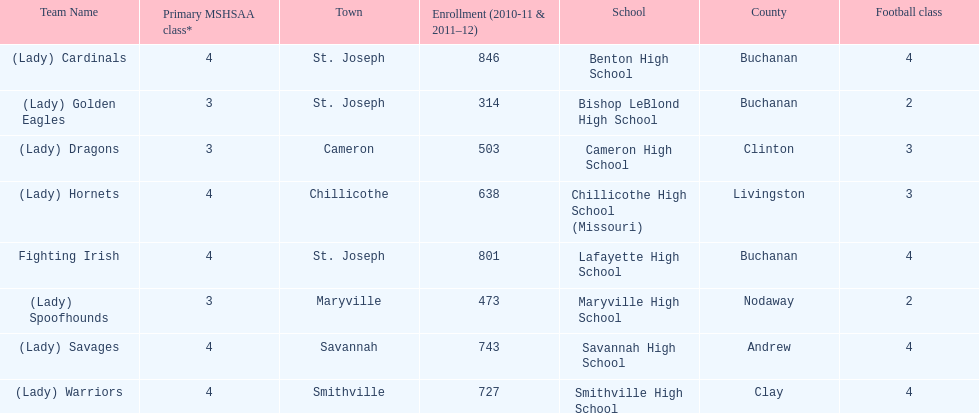Which school has the least amount of student enrollment between 2010-2011 and 2011-2012? Bishop LeBlond High School. 